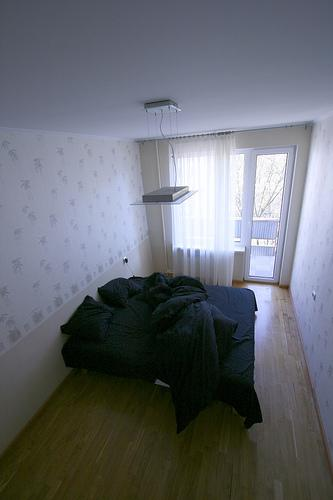Question: what room is shown?
Choices:
A. Living room.
B. Bathroom.
C. Bedroom.
D. Kitchen.
Answer with the letter. Answer: C Question: where is the bed in the room?
Choices:
A. The center.
B. On the right.
C. On the left.
D. In the back.
Answer with the letter. Answer: A Question: what is hanging from the ceiling?
Choices:
A. Lights.
B. Cobwebs.
C. Fan.
D. Party Streamers.
Answer with the letter. Answer: A Question: what color is the bed?
Choices:
A. Black.
B. Onyx.
C. Ebony.
D. Dark brown.
Answer with the letter. Answer: A Question: how many pillows can be seen?
Choices:
A. Four.
B. Five.
C. One.
D. Two.
Answer with the letter. Answer: D 